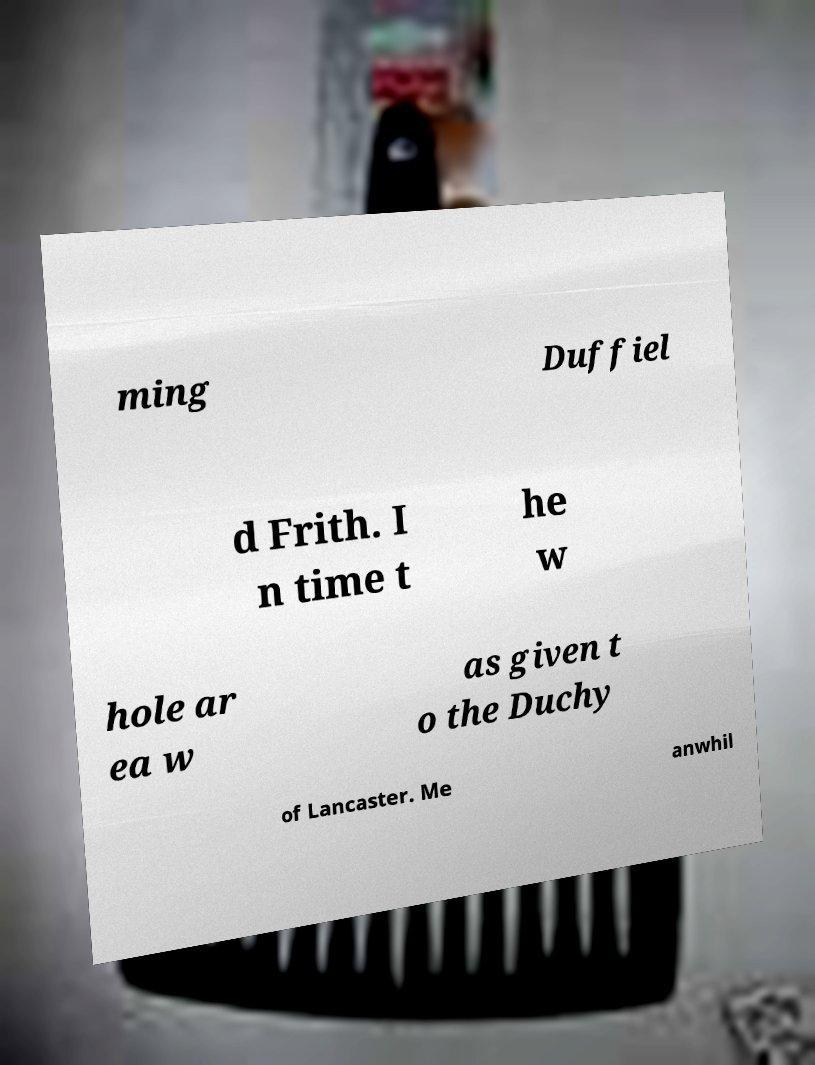I need the written content from this picture converted into text. Can you do that? ming Duffiel d Frith. I n time t he w hole ar ea w as given t o the Duchy of Lancaster. Me anwhil 